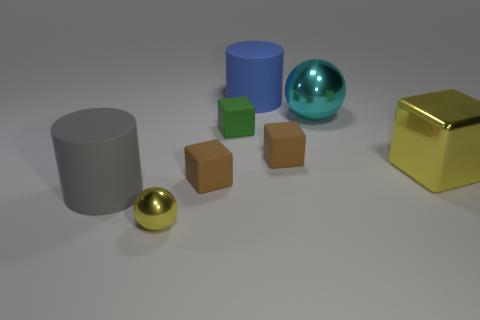Do the tiny green matte thing and the large rubber thing to the right of the yellow ball have the same shape?
Your answer should be very brief. No. There is a shiny thing that is left of the brown block on the left side of the large blue matte cylinder; what size is it?
Ensure brevity in your answer.  Small. Are there the same number of tiny things that are on the left side of the small metallic ball and large yellow things that are to the left of the cyan sphere?
Give a very brief answer. Yes. The large metal thing that is the same shape as the small yellow shiny thing is what color?
Offer a very short reply. Cyan. How many large cylinders are the same color as the small sphere?
Provide a succinct answer. 0. There is a tiny green matte thing that is on the right side of the gray rubber cylinder; is its shape the same as the blue matte thing?
Offer a very short reply. No. There is a small brown rubber object on the right side of the brown rubber block left of the large rubber object that is behind the cyan object; what is its shape?
Your answer should be compact. Cube. What size is the cyan object?
Ensure brevity in your answer.  Large. What color is the big ball that is the same material as the tiny sphere?
Offer a terse response. Cyan. What number of other yellow objects have the same material as the tiny yellow thing?
Your answer should be very brief. 1. 